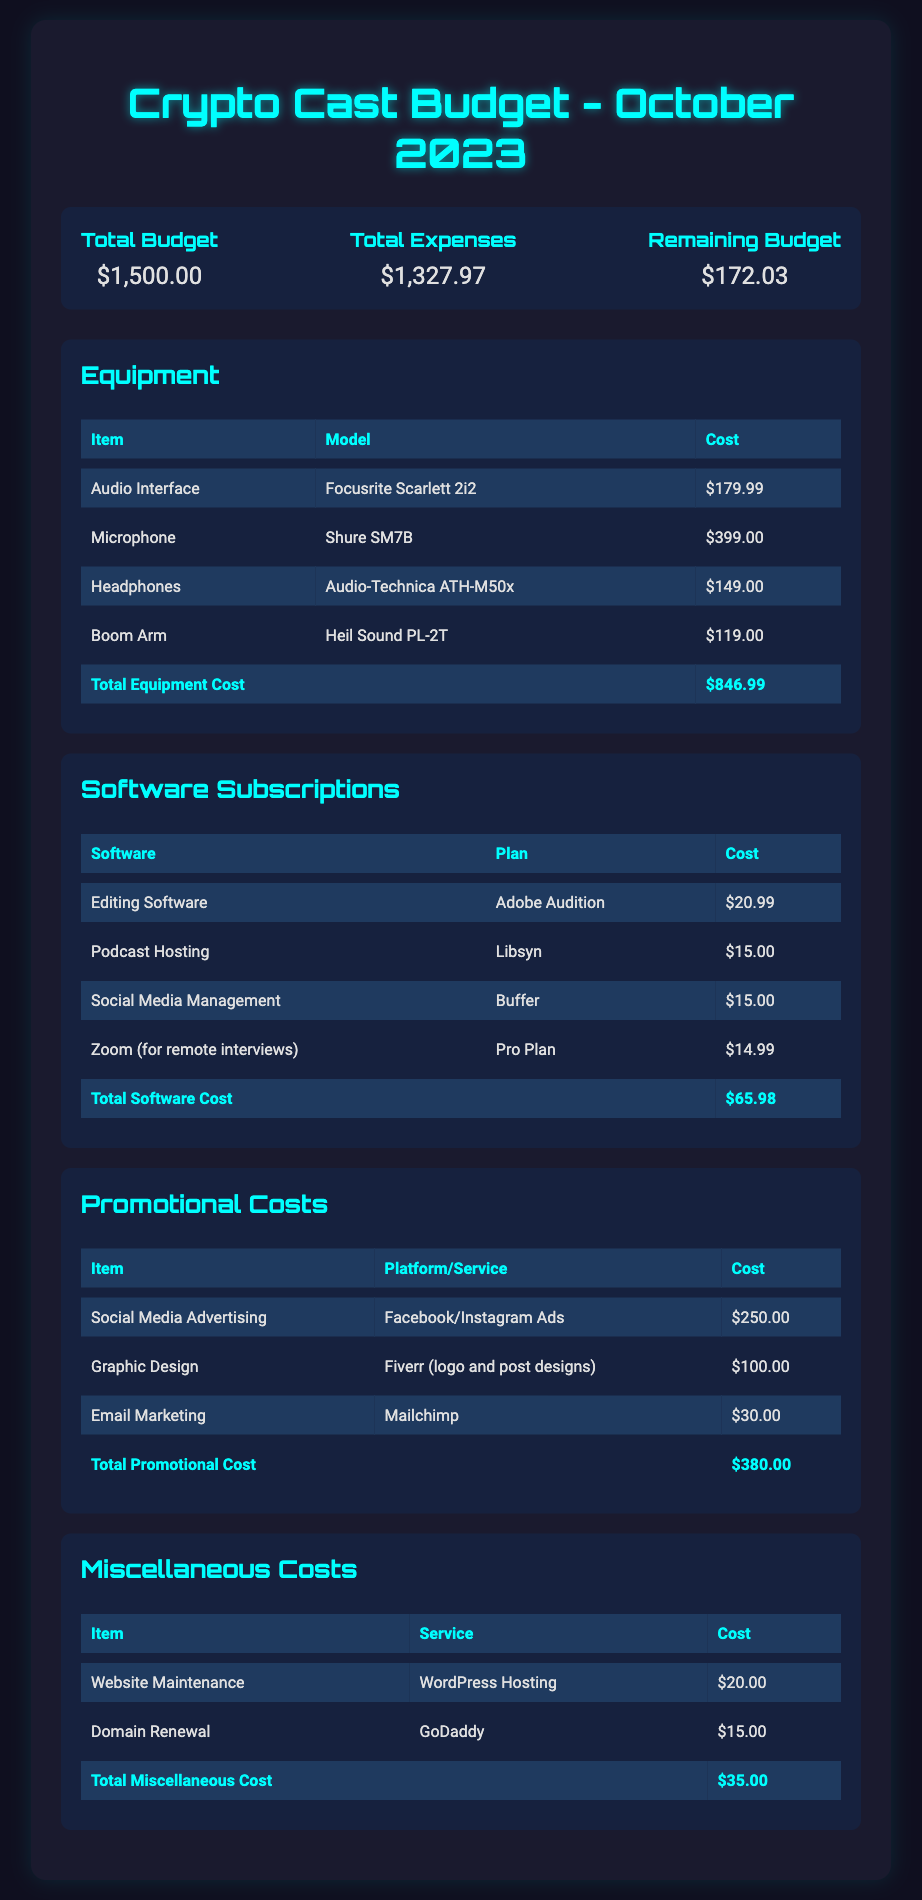What is the total budget for October 2023? The total budget is listed at the top of the document under the budget summary section.
Answer: $1,500.00 What is the total expense for October 2023? The total expenses are provided in the budget summary section of the document.
Answer: $1,327.97 How much remaining budget is there for October 2023? The remaining budget is shown in the budget summary section after the total expenses.
Answer: $172.03 What is the cost of the Shure SM7B microphone? The cost of the Shure SM7B microphone can be found in the Equipment section of the document.
Answer: $399.00 What is the total cost for software subscriptions? The total cost for software subscriptions is summarized in the Software Subscriptions section at the end of its table.
Answer: $65.98 What platform is used for social media advertising? The platform for social media advertising is mentioned under the Promotional Costs section.
Answer: Facebook/Instagram Ads How much is spent on graphic design? The cost of graphic design is listed in the Promotional Costs table.
Answer: $100.00 What is the total cost for equipment? The total equipment cost is provided at the bottom of the Equipment table.
Answer: $846.99 How much is allocated to email marketing? The email marketing cost can be found in the Promotional Costs section of the document.
Answer: $30.00 